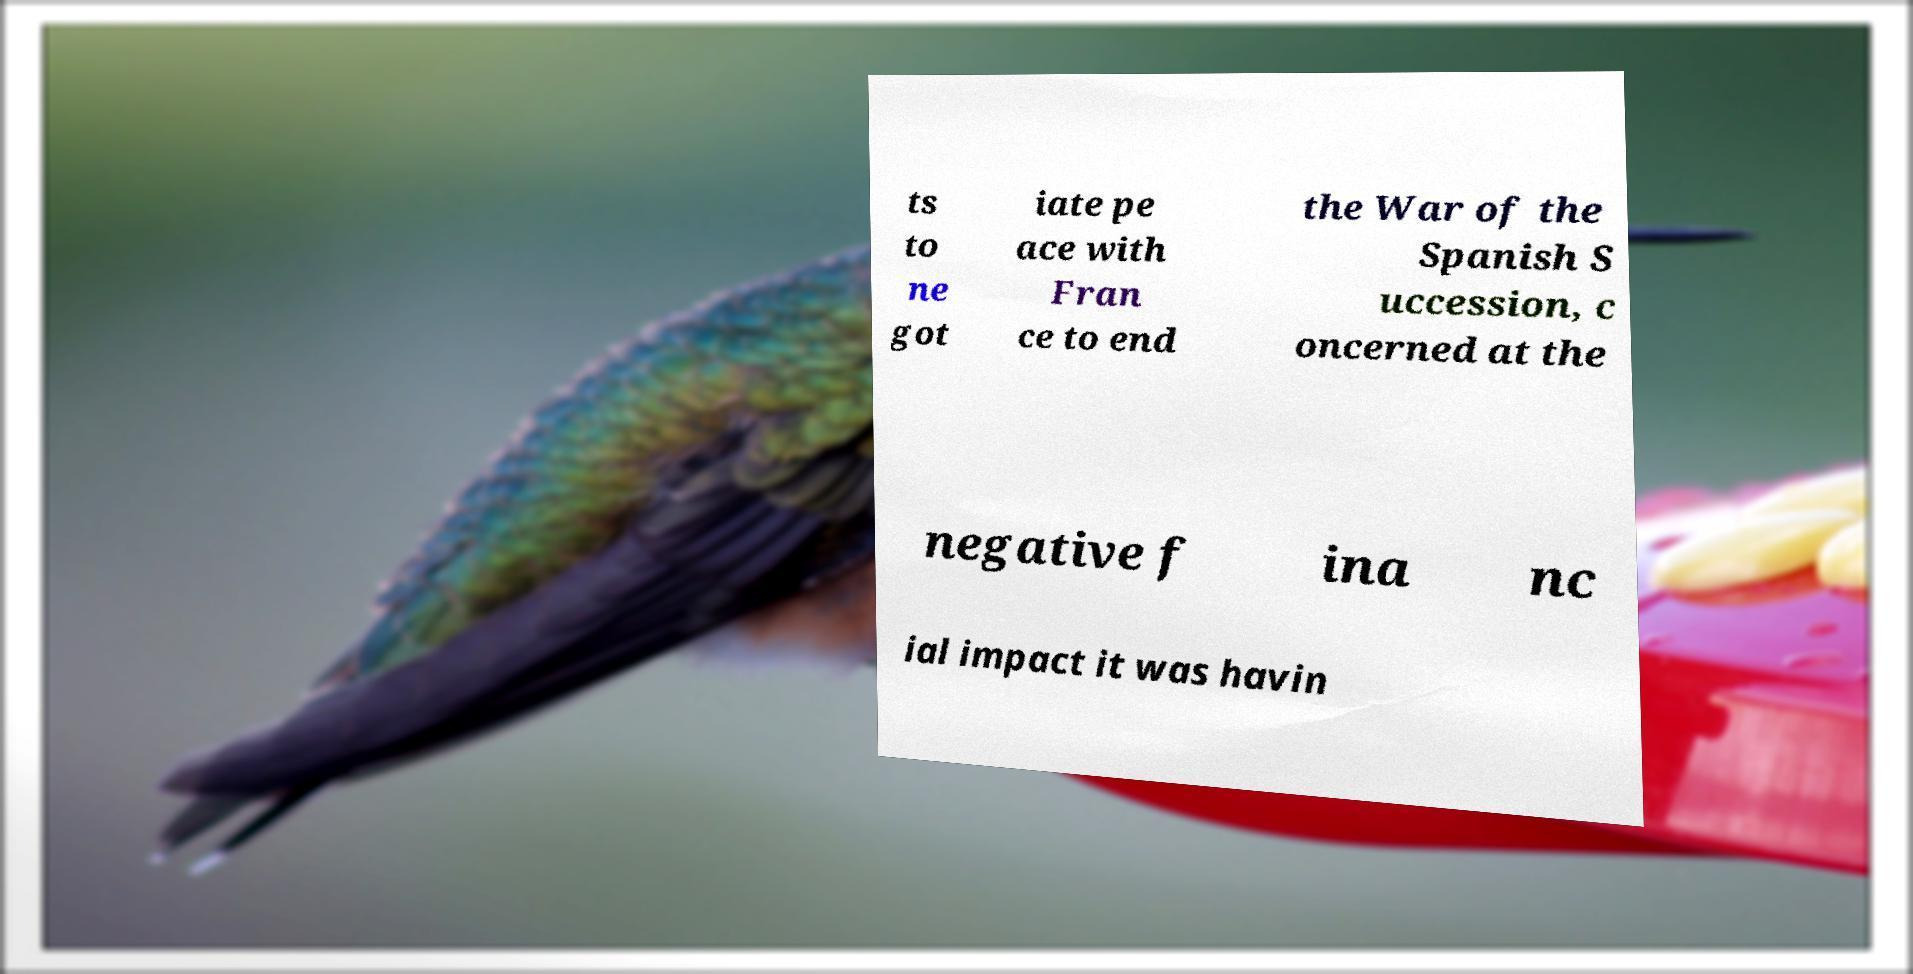Please read and relay the text visible in this image. What does it say? ts to ne got iate pe ace with Fran ce to end the War of the Spanish S uccession, c oncerned at the negative f ina nc ial impact it was havin 